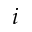<formula> <loc_0><loc_0><loc_500><loc_500>i</formula> 